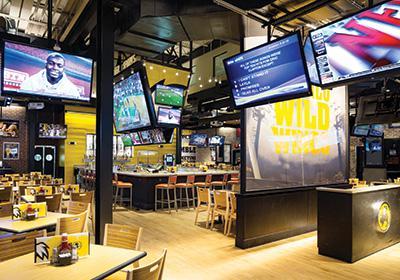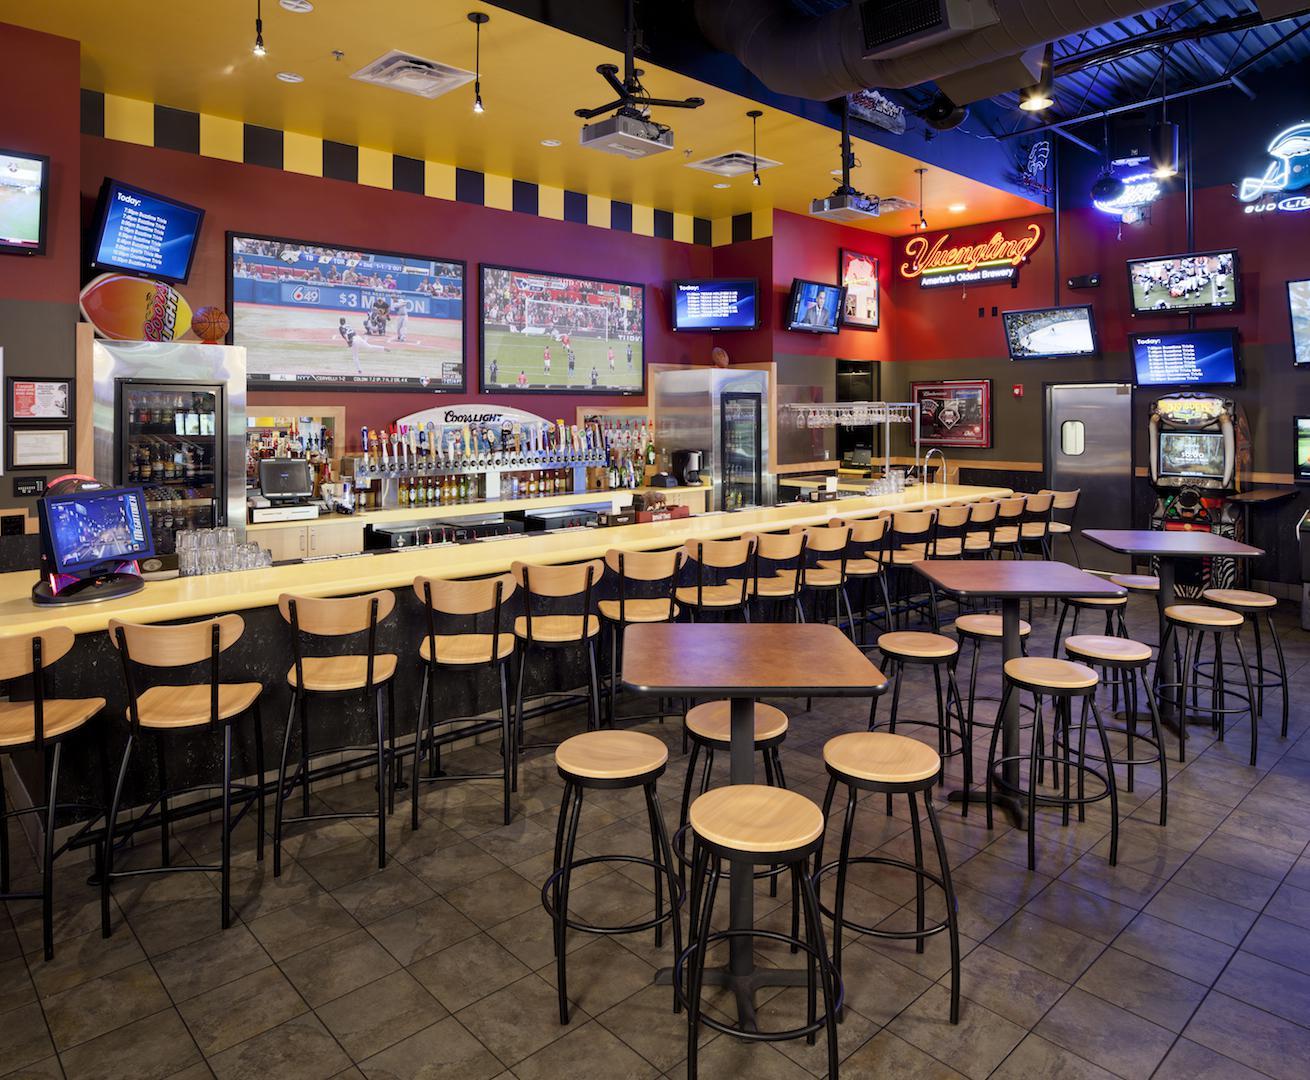The first image is the image on the left, the second image is the image on the right. Given the left and right images, does the statement "A yellow wall can be seen in the background of the left image." hold true? Answer yes or no. Yes. The first image is the image on the left, the second image is the image on the right. For the images shown, is this caption "One bar area has a yellow ceiling and stools with backs at the bar." true? Answer yes or no. Yes. 